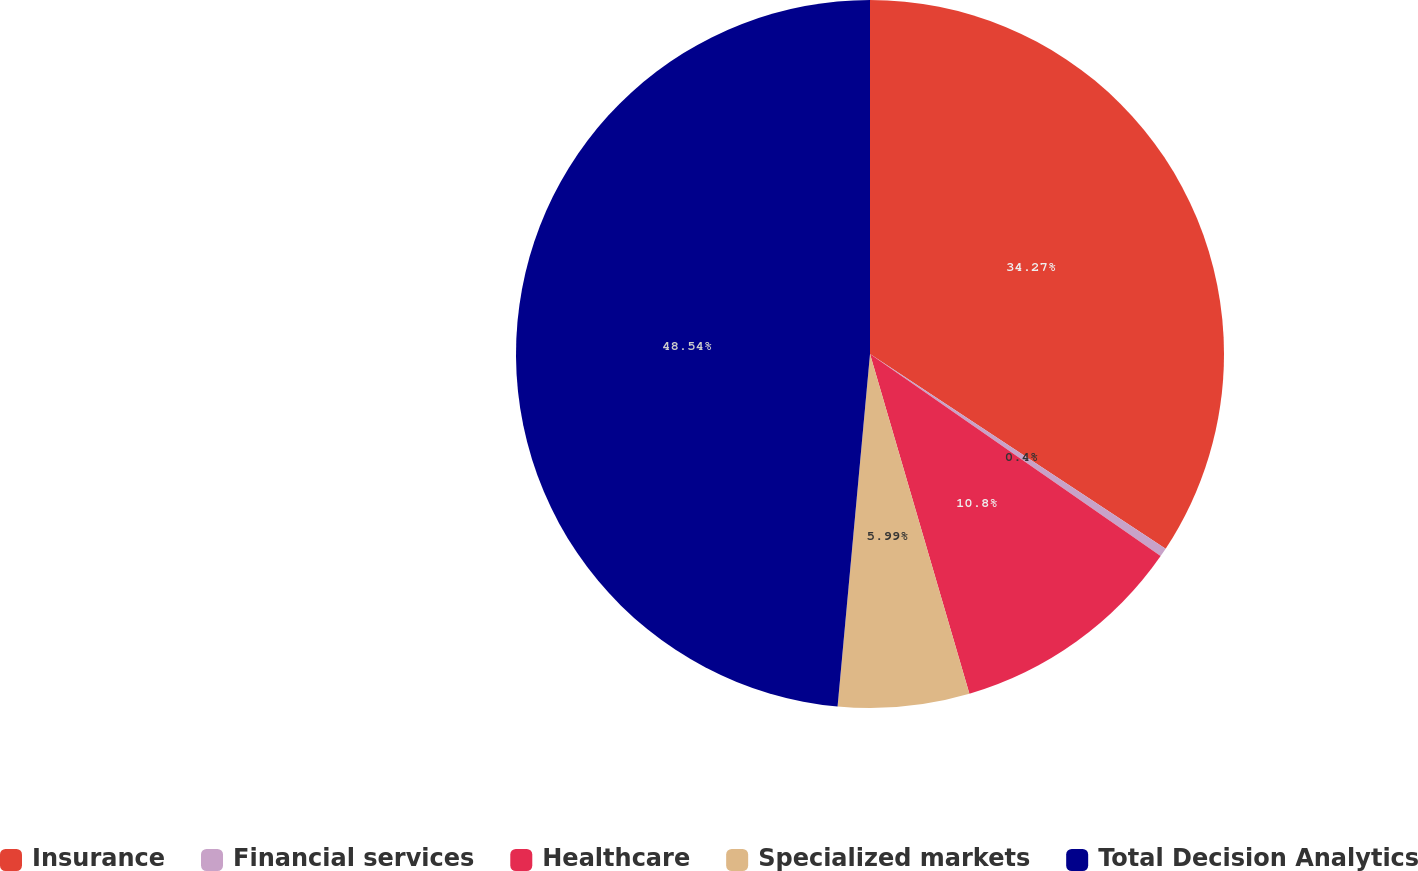<chart> <loc_0><loc_0><loc_500><loc_500><pie_chart><fcel>Insurance<fcel>Financial services<fcel>Healthcare<fcel>Specialized markets<fcel>Total Decision Analytics<nl><fcel>34.27%<fcel>0.4%<fcel>10.8%<fcel>5.99%<fcel>48.54%<nl></chart> 